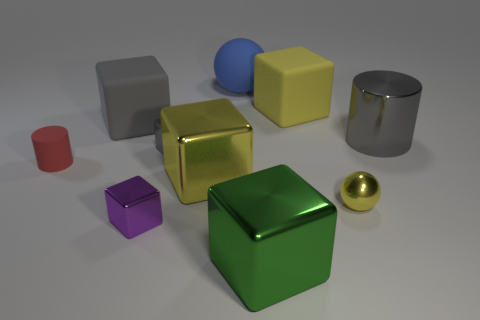Which objects in the image appear to have a matte surface finish? The objects with a matte surface finish are the red cylinder, the blue sphere, and the yellow cube. Unlike their glossy counterparts, these objects do not reflect light in a specular way, resulting in a non-shiny appearance. 